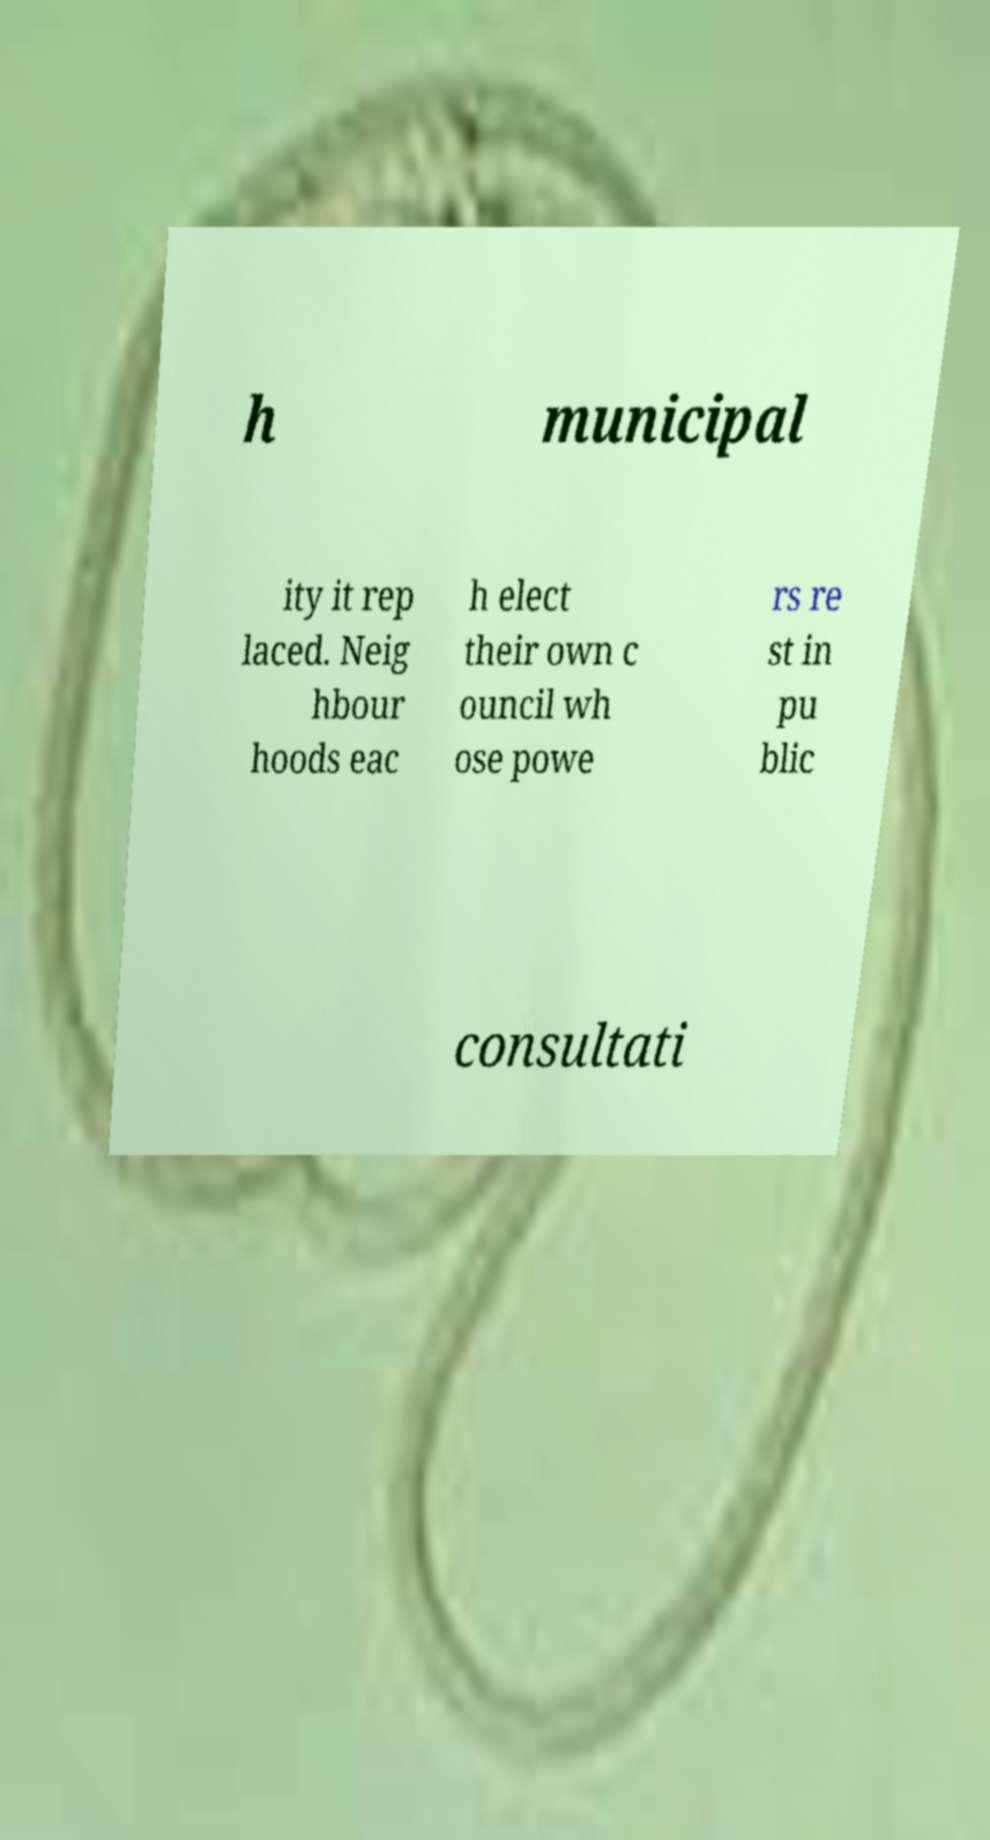Could you assist in decoding the text presented in this image and type it out clearly? h municipal ity it rep laced. Neig hbour hoods eac h elect their own c ouncil wh ose powe rs re st in pu blic consultati 